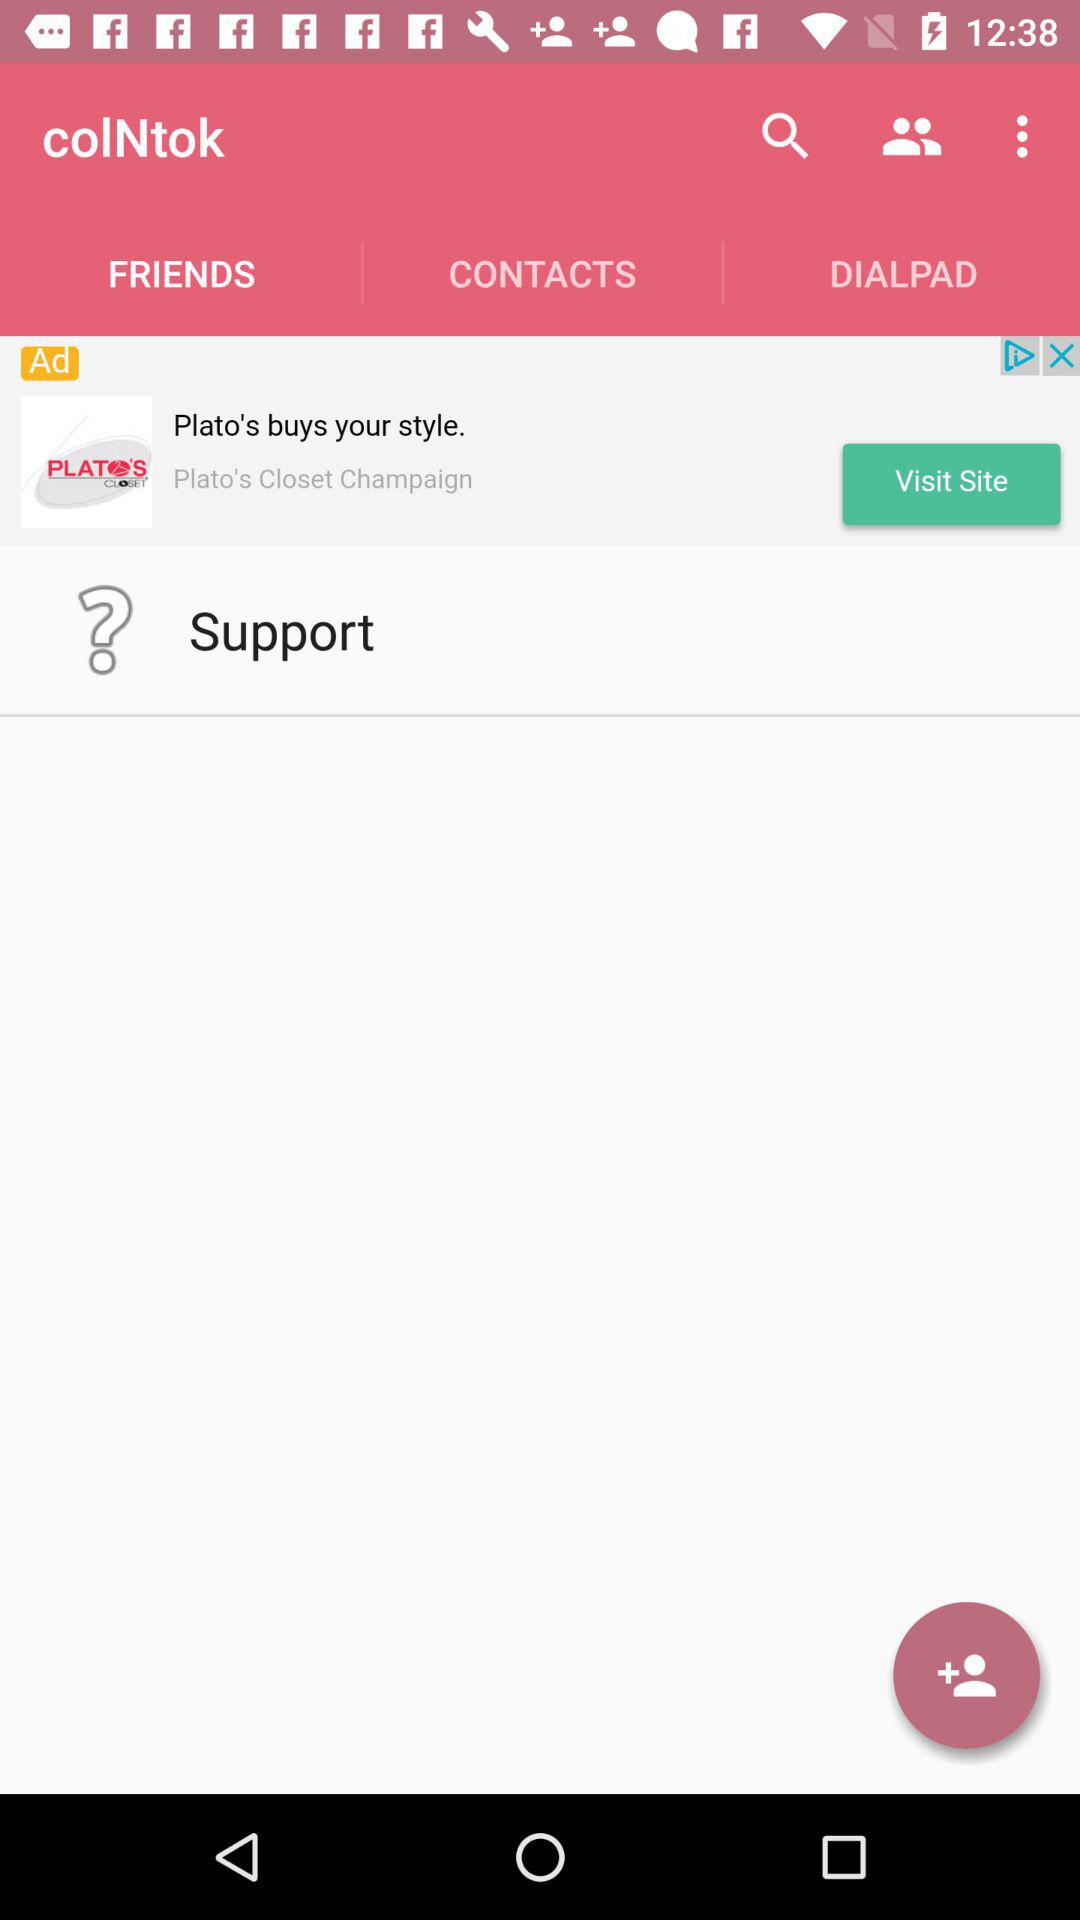What is the name of the application? The name of the application is "colNtok". 